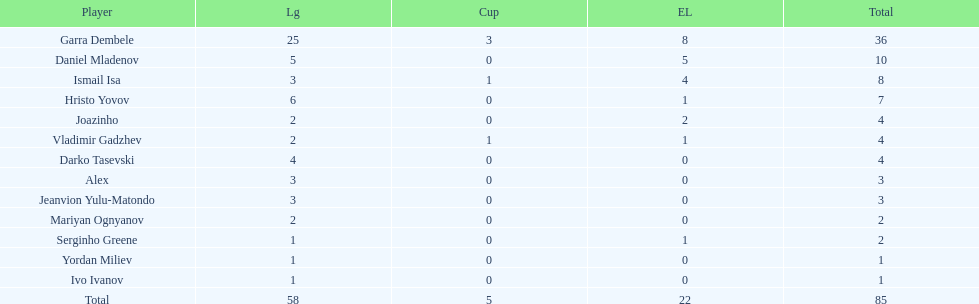I'm looking to parse the entire table for insights. Could you assist me with that? {'header': ['Player', 'Lg', 'Cup', 'EL', 'Total'], 'rows': [['Garra Dembele', '25', '3', '8', '36'], ['Daniel Mladenov', '5', '0', '5', '10'], ['Ismail Isa', '3', '1', '4', '8'], ['Hristo Yovov', '6', '0', '1', '7'], ['Joazinho', '2', '0', '2', '4'], ['Vladimir Gadzhev', '2', '1', '1', '4'], ['Darko Tasevski', '4', '0', '0', '4'], ['Alex', '3', '0', '0', '3'], ['Jeanvion Yulu-Matondo', '3', '0', '0', '3'], ['Mariyan Ognyanov', '2', '0', '0', '2'], ['Serginho Greene', '1', '0', '1', '2'], ['Yordan Miliev', '1', '0', '0', '1'], ['Ivo Ivanov', '1', '0', '0', '1'], ['Total', '58', '5', '22', '85']]} Which players only scored one goal? Serginho Greene, Yordan Miliev, Ivo Ivanov. 